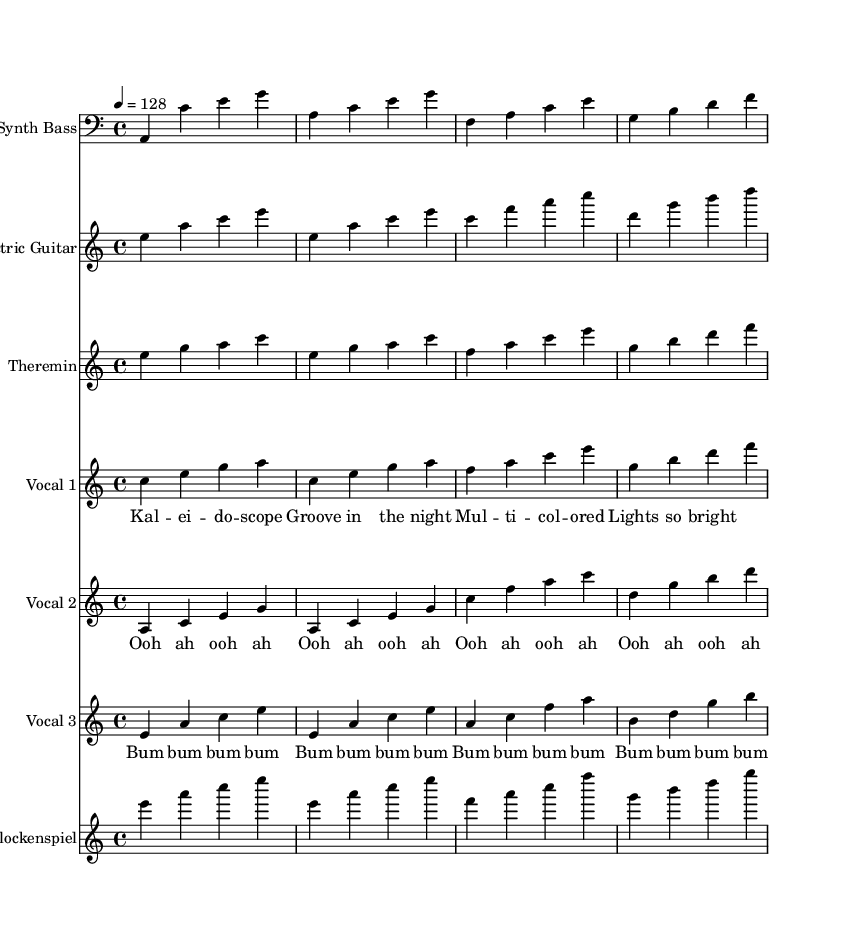What is the key signature of this music? The key signature indicates A minor, which is noted by having no sharps or flats. In the global section, the key is established at the beginning of the score.
Answer: A minor What is the time signature of this music? The time signature is noted as 4/4, which means there are four beats in each measure and the quarter note gets one beat. This is evident in the global section.
Answer: 4/4 What is the tempo marking for this piece? The tempo marking is indicated as a quarter note equals 128 beats per minute. This is found in the global section, signifying the speed of the piece.
Answer: 128 How many vocal harmonies are present in the score? There are three vocal harmony parts shown in separate staves with their respective melody lines and lyrics. This is determined by counting the distinct vocal staff entries.
Answer: 3 Which instrument plays the bass line? The bass line is played by the Synth Bass, indicated clearly on its own staff in the score's instrumental layout.
Answer: Synth Bass What is the primary theme of the lyrics in the first vocal harmony? The primary theme of the lyrics revolves around nighttime visuals and colorful lights, as seen in the lyrics provided for Vocal 1.
Answer: Nighttime visuals How is the use of the theremin significant in this piece? The theremin adds an unconventional sound texture to the house music genre, enhancing its funky feel, evidenced by its distinctive melodic line in the score.
Answer: Unconventional sound texture 